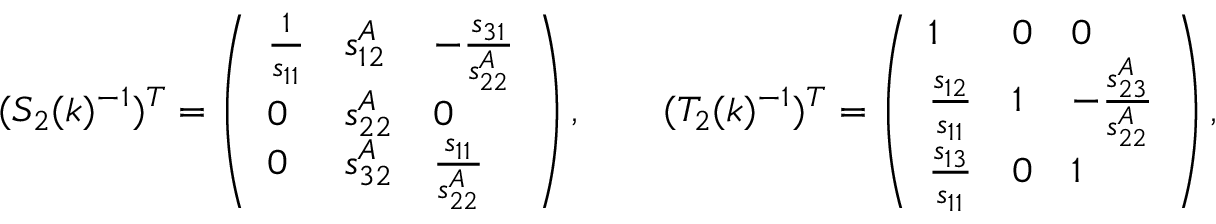<formula> <loc_0><loc_0><loc_500><loc_500>\begin{array} { r } { ( S _ { 2 } ( k ) ^ { - 1 } ) ^ { T } = \left ( \begin{array} { l l l } { \frac { 1 } { s _ { 1 1 } } } & { s _ { 1 2 } ^ { A } } & { - \frac { s _ { 3 1 } } { s _ { 2 2 } ^ { A } } } \\ { 0 } & { s _ { 2 2 } ^ { A } } & { 0 } \\ { 0 } & { s _ { 3 2 } ^ { A } } & { \frac { s _ { 1 1 } } { s _ { 2 2 } ^ { A } } } \end{array} \right ) , \quad ( T _ { 2 } ( k ) ^ { - 1 } ) ^ { T } = \left ( \begin{array} { l l l } { 1 } & { 0 } & { 0 } \\ { \frac { s _ { 1 2 } } { s _ { 1 1 } } } & { 1 } & { - \frac { s _ { 2 3 } ^ { A } } { s _ { 2 2 } ^ { A } } } \\ { \frac { s _ { 1 3 } } { s _ { 1 1 } } } & { 0 } & { 1 } \end{array} \right ) , } \end{array}</formula> 